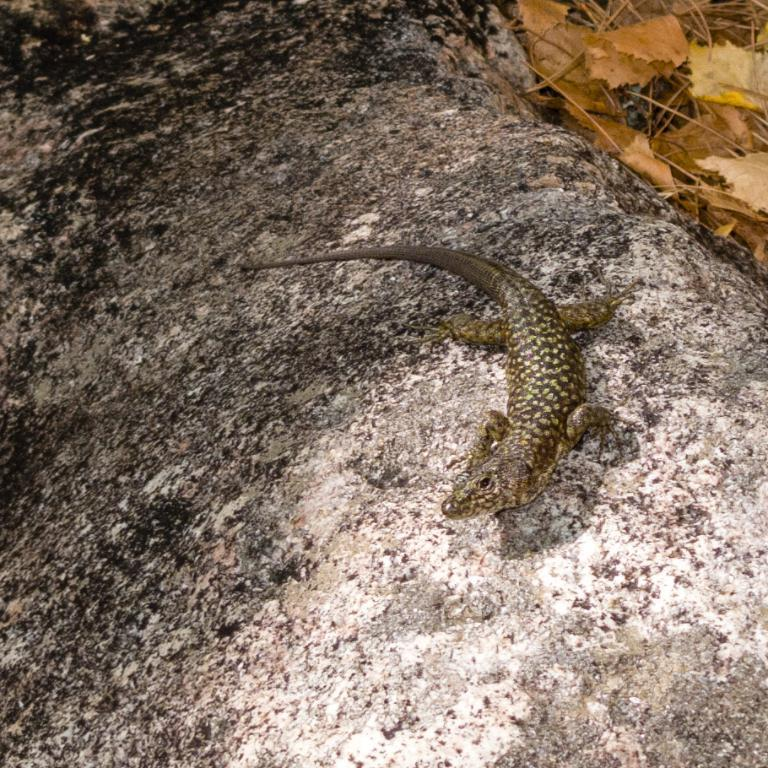What type of animal is in the image? There is a reptile in the image. Where is the reptile located? The reptile is on a rock. What can be seen in the background of the image? There are dried leaves visible in the image. How many properties does the reptile own in the image? The reptile does not own any properties in the image, as it is an animal and not a person. 